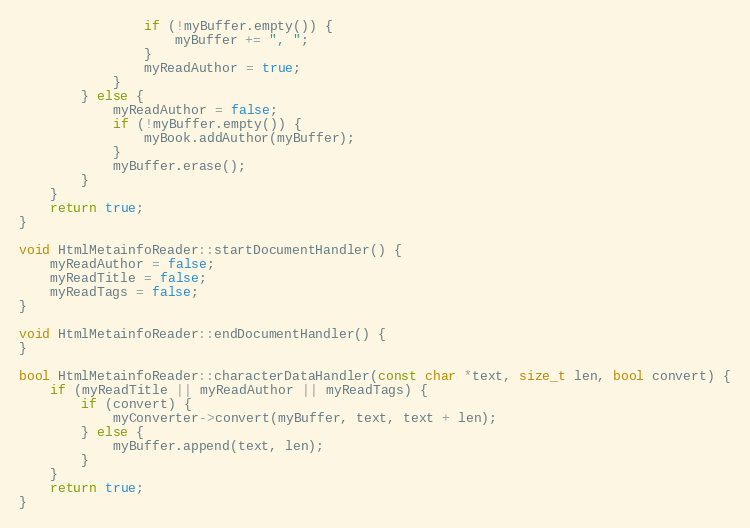Convert code to text. <code><loc_0><loc_0><loc_500><loc_500><_C++_>				if (!myBuffer.empty()) {
					myBuffer += ", ";
				}
				myReadAuthor = true;
			}
		} else {
			myReadAuthor = false;
			if (!myBuffer.empty()) {
				myBook.addAuthor(myBuffer);
			}
			myBuffer.erase();
		}
	}
	return true;
}

void HtmlMetainfoReader::startDocumentHandler() {
	myReadAuthor = false;
	myReadTitle = false;
	myReadTags = false;
}

void HtmlMetainfoReader::endDocumentHandler() {
}

bool HtmlMetainfoReader::characterDataHandler(const char *text, size_t len, bool convert) {
	if (myReadTitle || myReadAuthor || myReadTags) {
		if (convert) {
			myConverter->convert(myBuffer, text, text + len);
		} else {
			myBuffer.append(text, len);
		}
	}
	return true;
}
</code> 